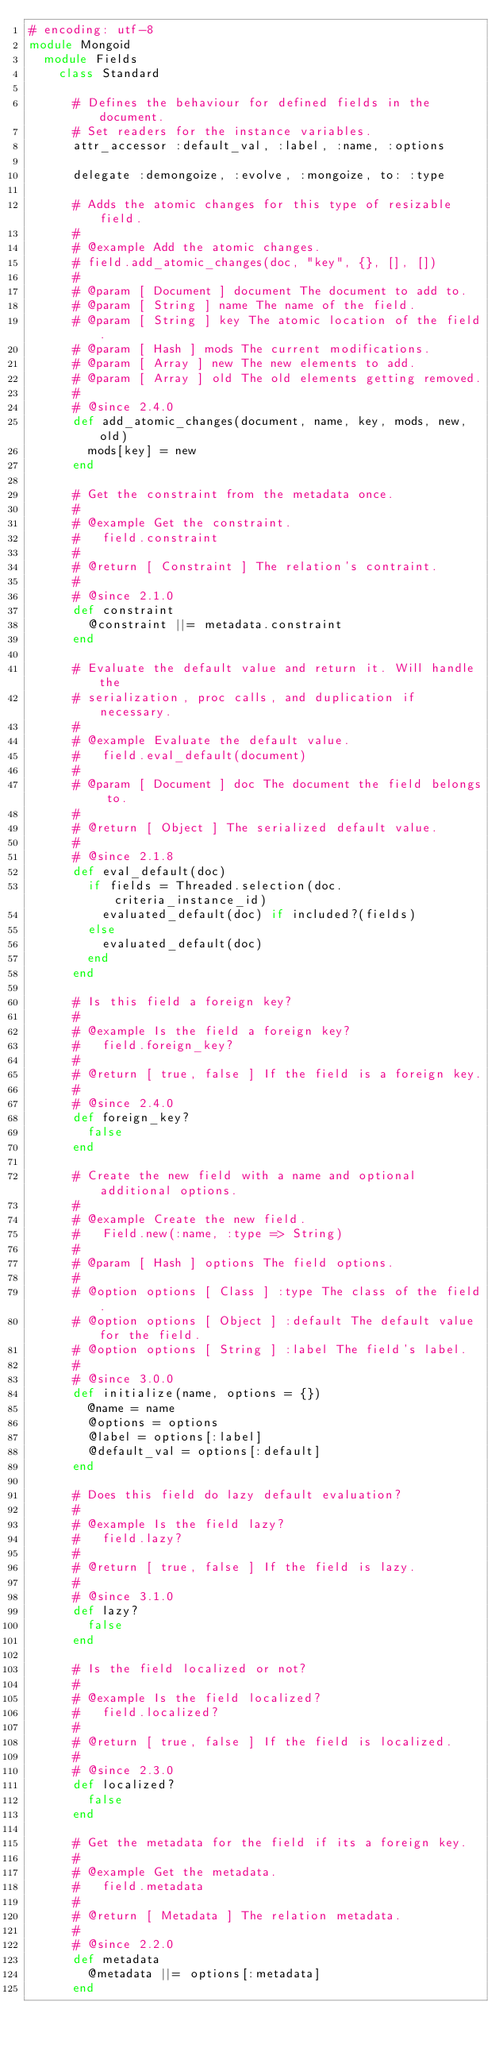Convert code to text. <code><loc_0><loc_0><loc_500><loc_500><_Ruby_># encoding: utf-8
module Mongoid
  module Fields
    class Standard

      # Defines the behaviour for defined fields in the document.
      # Set readers for the instance variables.
      attr_accessor :default_val, :label, :name, :options

      delegate :demongoize, :evolve, :mongoize, to: :type

      # Adds the atomic changes for this type of resizable field.
      #
      # @example Add the atomic changes.
      # field.add_atomic_changes(doc, "key", {}, [], [])
      #
      # @param [ Document ] document The document to add to.
      # @param [ String ] name The name of the field.
      # @param [ String ] key The atomic location of the field.
      # @param [ Hash ] mods The current modifications.
      # @param [ Array ] new The new elements to add.
      # @param [ Array ] old The old elements getting removed.
      #
      # @since 2.4.0
      def add_atomic_changes(document, name, key, mods, new, old)
        mods[key] = new
      end

      # Get the constraint from the metadata once.
      #
      # @example Get the constraint.
      #   field.constraint
      #
      # @return [ Constraint ] The relation's contraint.
      #
      # @since 2.1.0
      def constraint
        @constraint ||= metadata.constraint
      end

      # Evaluate the default value and return it. Will handle the
      # serialization, proc calls, and duplication if necessary.
      #
      # @example Evaluate the default value.
      #   field.eval_default(document)
      #
      # @param [ Document ] doc The document the field belongs to.
      #
      # @return [ Object ] The serialized default value.
      #
      # @since 2.1.8
      def eval_default(doc)
        if fields = Threaded.selection(doc.criteria_instance_id)
          evaluated_default(doc) if included?(fields)
        else
          evaluated_default(doc)
        end
      end

      # Is this field a foreign key?
      #
      # @example Is the field a foreign key?
      #   field.foreign_key?
      #
      # @return [ true, false ] If the field is a foreign key.
      #
      # @since 2.4.0
      def foreign_key?
        false
      end

      # Create the new field with a name and optional additional options.
      #
      # @example Create the new field.
      #   Field.new(:name, :type => String)
      #
      # @param [ Hash ] options The field options.
      #
      # @option options [ Class ] :type The class of the field.
      # @option options [ Object ] :default The default value for the field.
      # @option options [ String ] :label The field's label.
      #
      # @since 3.0.0
      def initialize(name, options = {})
        @name = name
        @options = options
        @label = options[:label]
        @default_val = options[:default]
      end

      # Does this field do lazy default evaluation?
      #
      # @example Is the field lazy?
      #   field.lazy?
      #
      # @return [ true, false ] If the field is lazy.
      #
      # @since 3.1.0
      def lazy?
        false
      end

      # Is the field localized or not?
      #
      # @example Is the field localized?
      #   field.localized?
      #
      # @return [ true, false ] If the field is localized.
      #
      # @since 2.3.0
      def localized?
        false
      end

      # Get the metadata for the field if its a foreign key.
      #
      # @example Get the metadata.
      #   field.metadata
      #
      # @return [ Metadata ] The relation metadata.
      #
      # @since 2.2.0
      def metadata
        @metadata ||= options[:metadata]
      end
</code> 